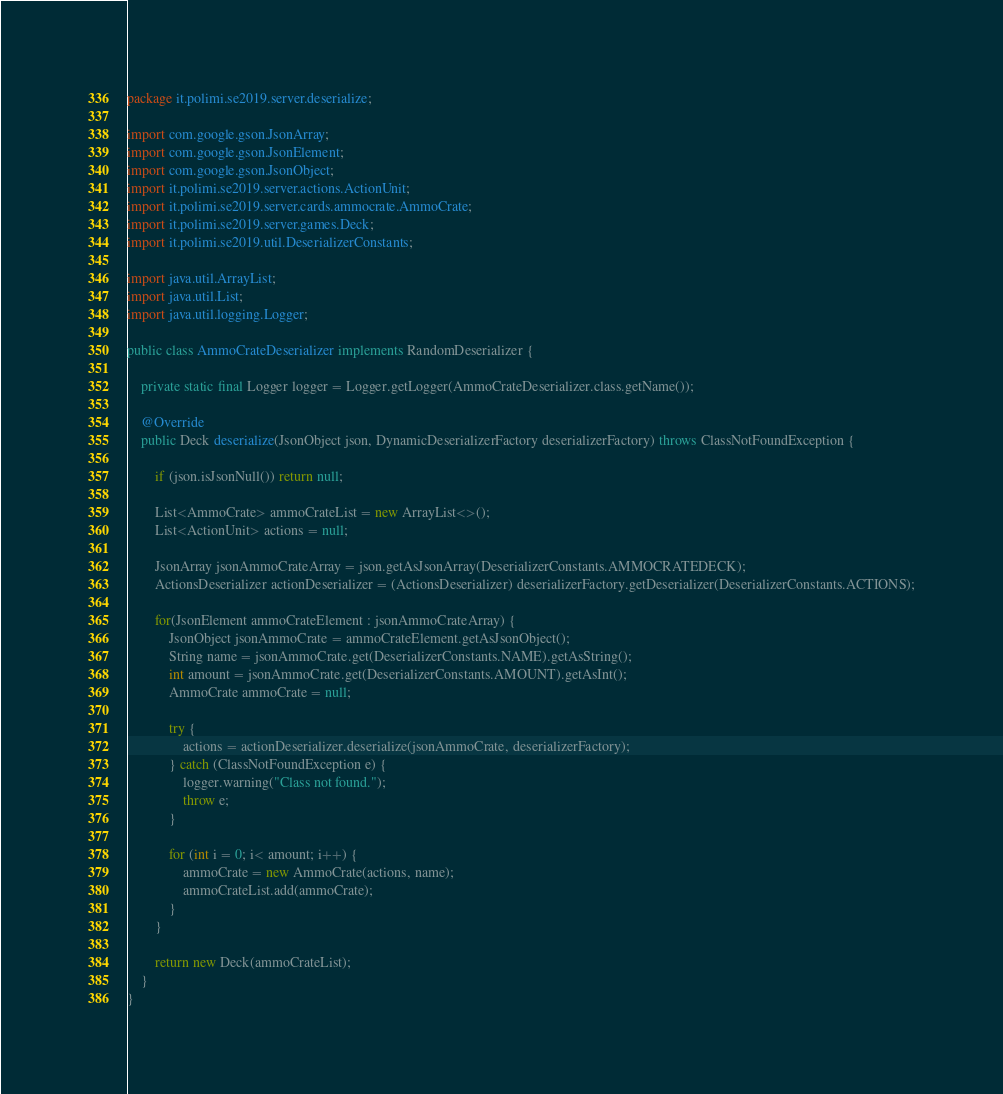<code> <loc_0><loc_0><loc_500><loc_500><_Java_>package it.polimi.se2019.server.deserialize;

import com.google.gson.JsonArray;
import com.google.gson.JsonElement;
import com.google.gson.JsonObject;
import it.polimi.se2019.server.actions.ActionUnit;
import it.polimi.se2019.server.cards.ammocrate.AmmoCrate;
import it.polimi.se2019.server.games.Deck;
import it.polimi.se2019.util.DeserializerConstants;

import java.util.ArrayList;
import java.util.List;
import java.util.logging.Logger;

public class AmmoCrateDeserializer implements RandomDeserializer {

    private static final Logger logger = Logger.getLogger(AmmoCrateDeserializer.class.getName());

    @Override
    public Deck deserialize(JsonObject json, DynamicDeserializerFactory deserializerFactory) throws ClassNotFoundException {

        if (json.isJsonNull()) return null;

        List<AmmoCrate> ammoCrateList = new ArrayList<>();
        List<ActionUnit> actions = null;

        JsonArray jsonAmmoCrateArray = json.getAsJsonArray(DeserializerConstants.AMMOCRATEDECK);
        ActionsDeserializer actionDeserializer = (ActionsDeserializer) deserializerFactory.getDeserializer(DeserializerConstants.ACTIONS);

        for(JsonElement ammoCrateElement : jsonAmmoCrateArray) {
            JsonObject jsonAmmoCrate = ammoCrateElement.getAsJsonObject();
            String name = jsonAmmoCrate.get(DeserializerConstants.NAME).getAsString();
            int amount = jsonAmmoCrate.get(DeserializerConstants.AMOUNT).getAsInt();
            AmmoCrate ammoCrate = null;

            try {
                actions = actionDeserializer.deserialize(jsonAmmoCrate, deserializerFactory);
            } catch (ClassNotFoundException e) {
                logger.warning("Class not found.");
                throw e;
            }

            for (int i = 0; i< amount; i++) {
                ammoCrate = new AmmoCrate(actions, name);
                ammoCrateList.add(ammoCrate);
            }
        }

        return new Deck(ammoCrateList);
    }
}
</code> 